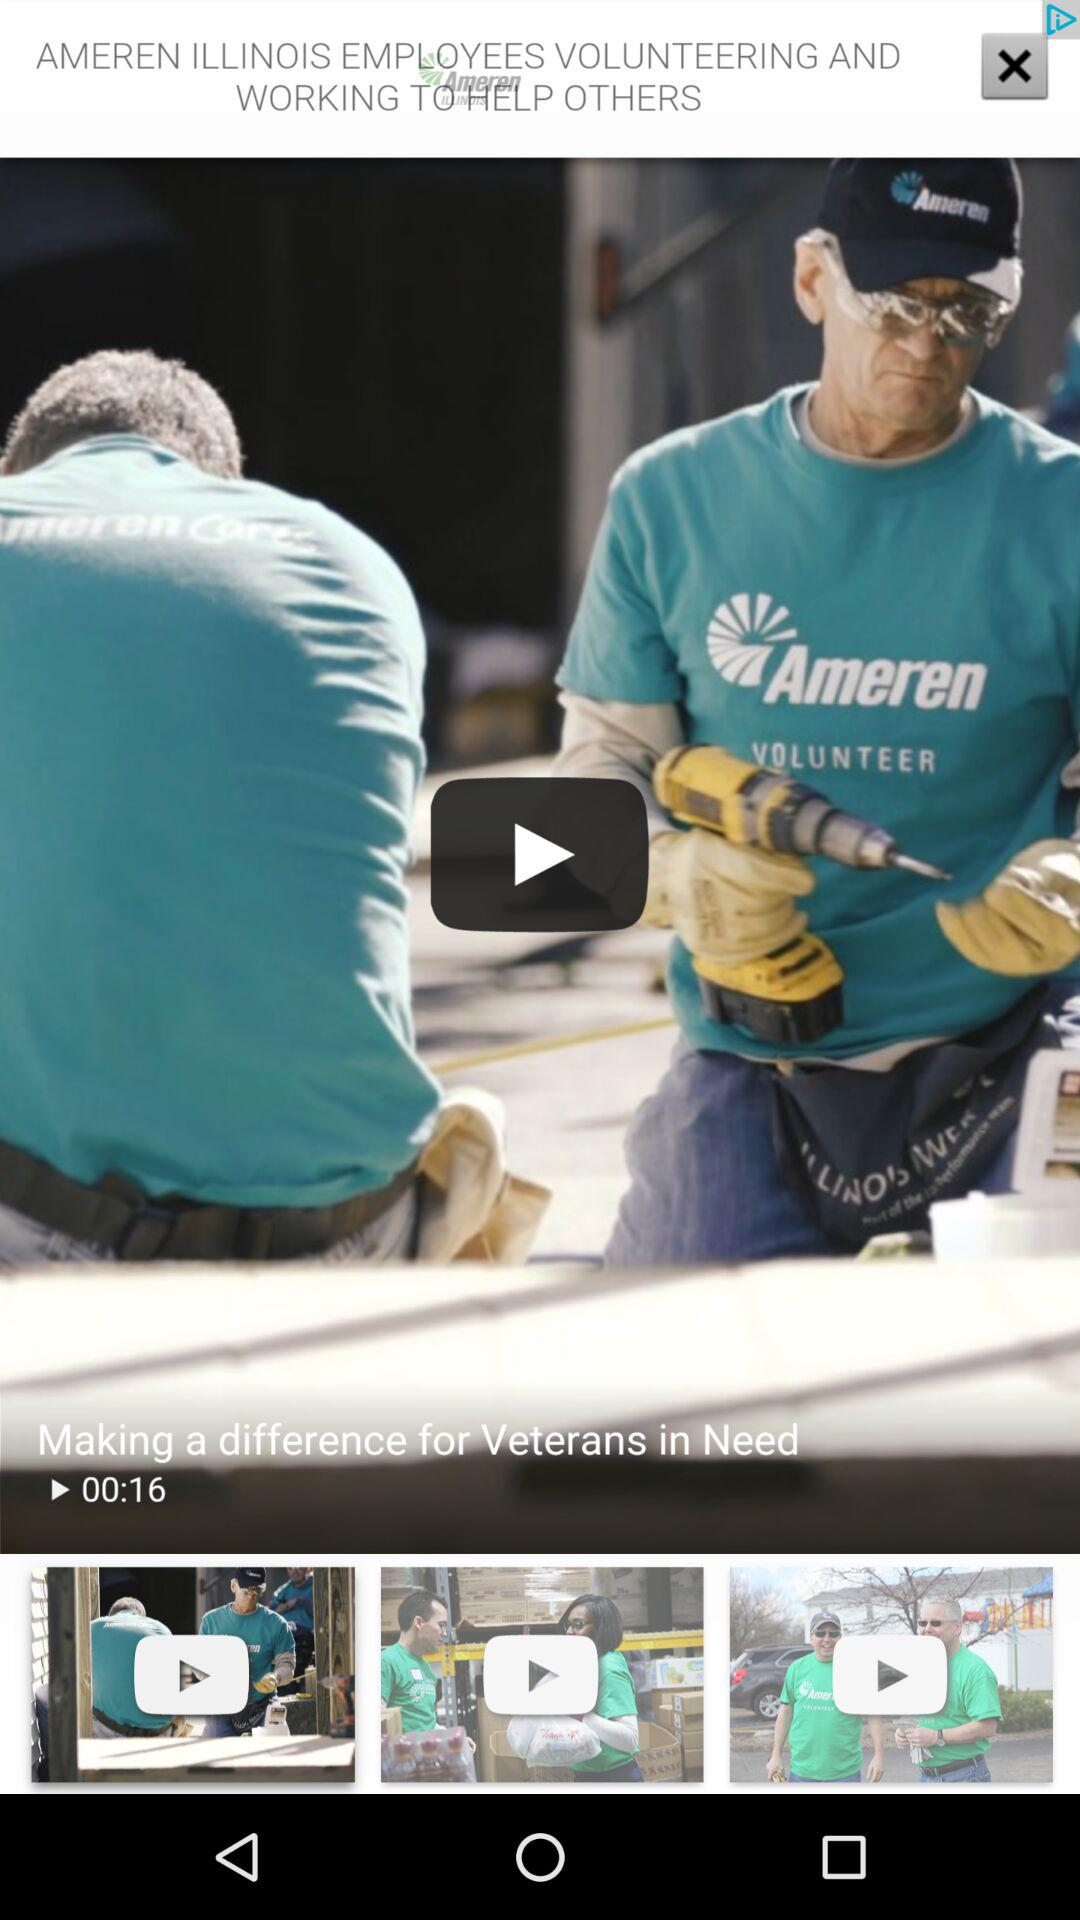How many seconds long is the video titled 'Making a difference for Veterans in Need'?
Answer the question using a single word or phrase. 16 